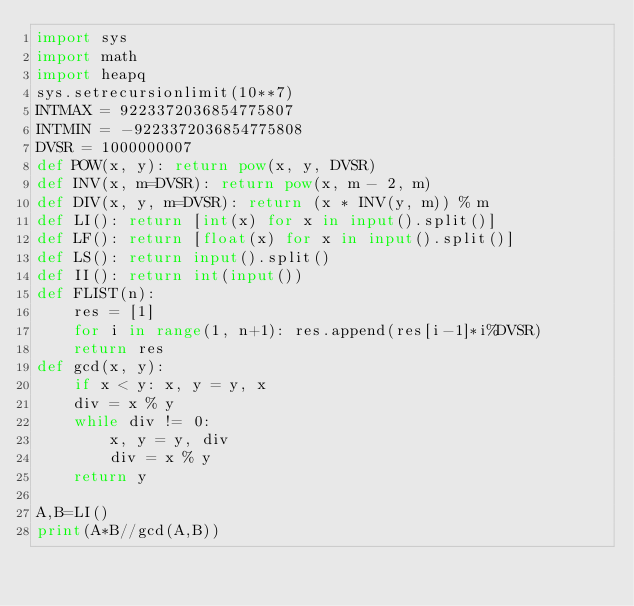<code> <loc_0><loc_0><loc_500><loc_500><_Python_>import sys
import math
import heapq
sys.setrecursionlimit(10**7)
INTMAX = 9223372036854775807
INTMIN = -9223372036854775808
DVSR = 1000000007
def POW(x, y): return pow(x, y, DVSR)
def INV(x, m=DVSR): return pow(x, m - 2, m)
def DIV(x, y, m=DVSR): return (x * INV(y, m)) % m
def LI(): return [int(x) for x in input().split()]
def LF(): return [float(x) for x in input().split()]
def LS(): return input().split()
def II(): return int(input())
def FLIST(n):
    res = [1]
    for i in range(1, n+1): res.append(res[i-1]*i%DVSR)
    return res
def gcd(x, y):
    if x < y: x, y = y, x
    div = x % y
    while div != 0:
        x, y = y, div
        div = x % y
    return y

A,B=LI()
print(A*B//gcd(A,B))
</code> 